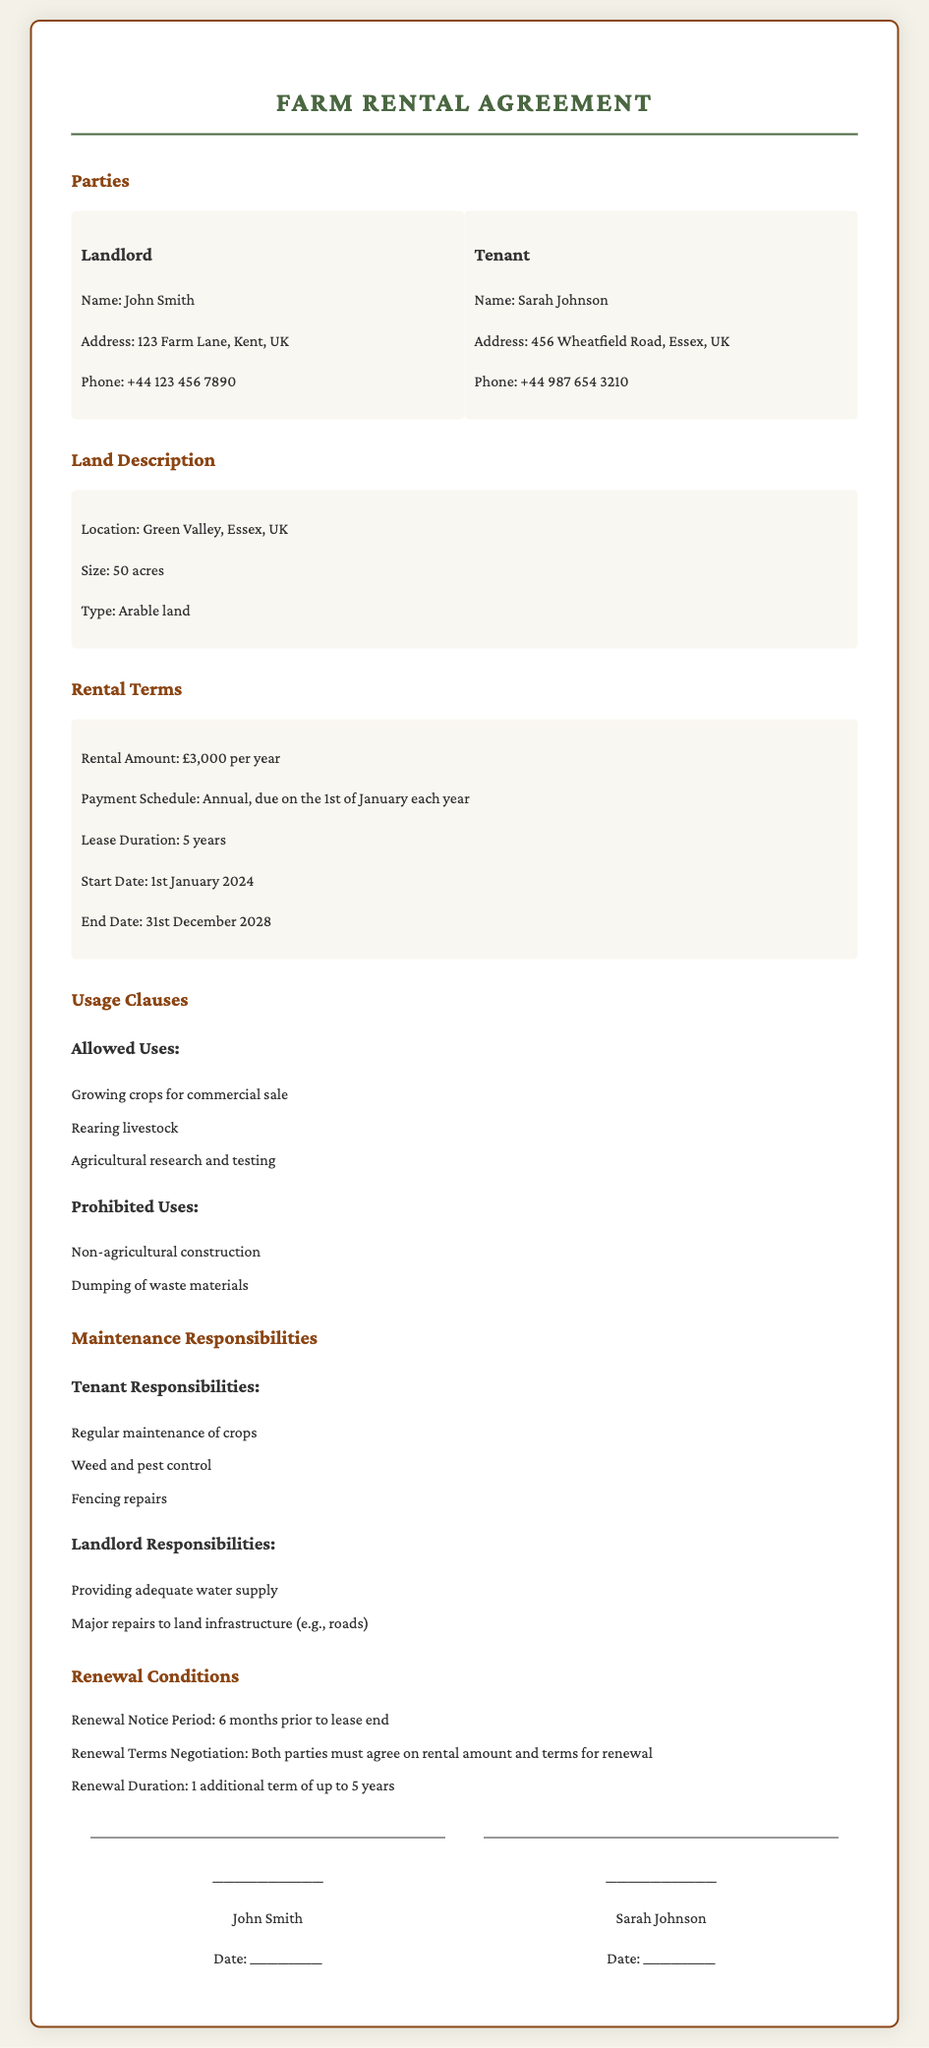What is the name of the landlord? The landlord's name is listed in the parties section of the document, which states "Landlord: John Smith."
Answer: John Smith What is the rental amount? The rental amount is specified in the rental terms section as "£3,000 per year."
Answer: £3,000 per year What is the duration of the lease? The lease duration is mentioned in the rental terms, which states "Lease Duration: 5 years."
Answer: 5 years When does the lease start? The start date is given in the rental terms section as "Start Date: 1st January 2024."
Answer: 1st January 2024 What are the allowed uses of the land? The document lists allowed uses, including "Growing crops for commercial sale."
Answer: Growing crops for commercial sale Who is responsible for weed and pest control? Tenant responsibilities listed state that "Weed and pest control" is the tenant's duty.
Answer: Tenant What is the renewal notice period? The renewal conditions state "Renewal Notice Period: 6 months prior to lease end."
Answer: 6 months What is the location of the land? The land description section provides the location as "Green Valley, Essex, UK."
Answer: Green Valley, Essex, UK What must both parties agree on for renewal? The renewal conditions indicate that both parties must agree on "rental amount and terms for renewal."
Answer: rental amount and terms for renewal 